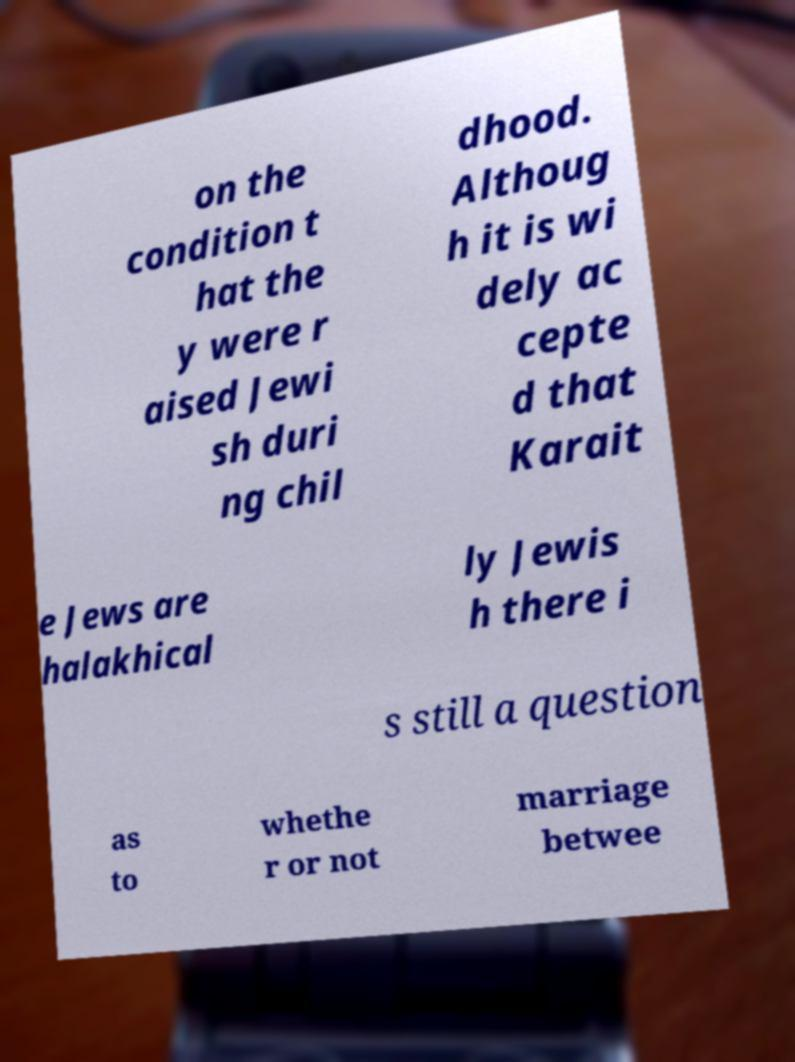Please read and relay the text visible in this image. What does it say? on the condition t hat the y were r aised Jewi sh duri ng chil dhood. Althoug h it is wi dely ac cepte d that Karait e Jews are halakhical ly Jewis h there i s still a question as to whethe r or not marriage betwee 